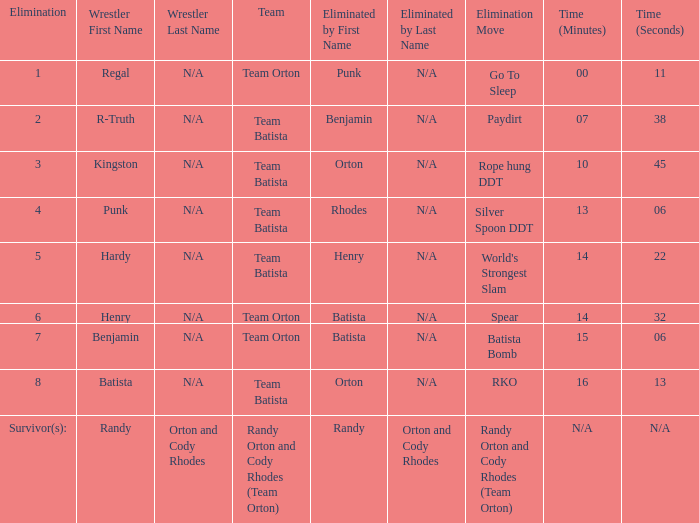What is the Elimination move listed against Regal? Go To Sleep. 